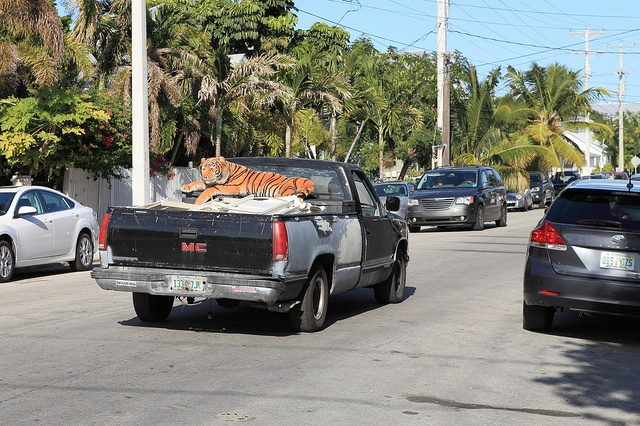Describe the objects in this image and their specific colors. I can see truck in gray, black, darkgray, and lightgray tones, car in gray, black, and lightgray tones, car in gray, lightgray, darkgray, and black tones, car in gray, black, navy, and darkgray tones, and car in gray, darkgray, blue, and navy tones in this image. 